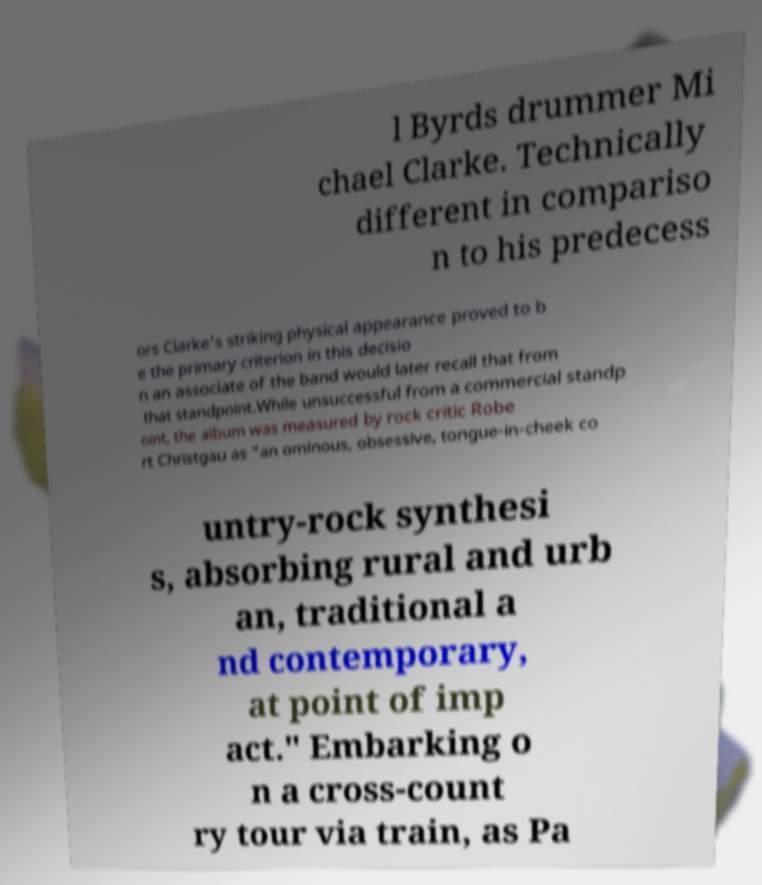Please identify and transcribe the text found in this image. l Byrds drummer Mi chael Clarke. Technically different in compariso n to his predecess ors Clarke's striking physical appearance proved to b e the primary criterion in this decisio n an associate of the band would later recall that from that standpoint.While unsuccessful from a commercial standp oint, the album was measured by rock critic Robe rt Christgau as "an ominous, obsessive, tongue-in-cheek co untry-rock synthesi s, absorbing rural and urb an, traditional a nd contemporary, at point of imp act." Embarking o n a cross-count ry tour via train, as Pa 